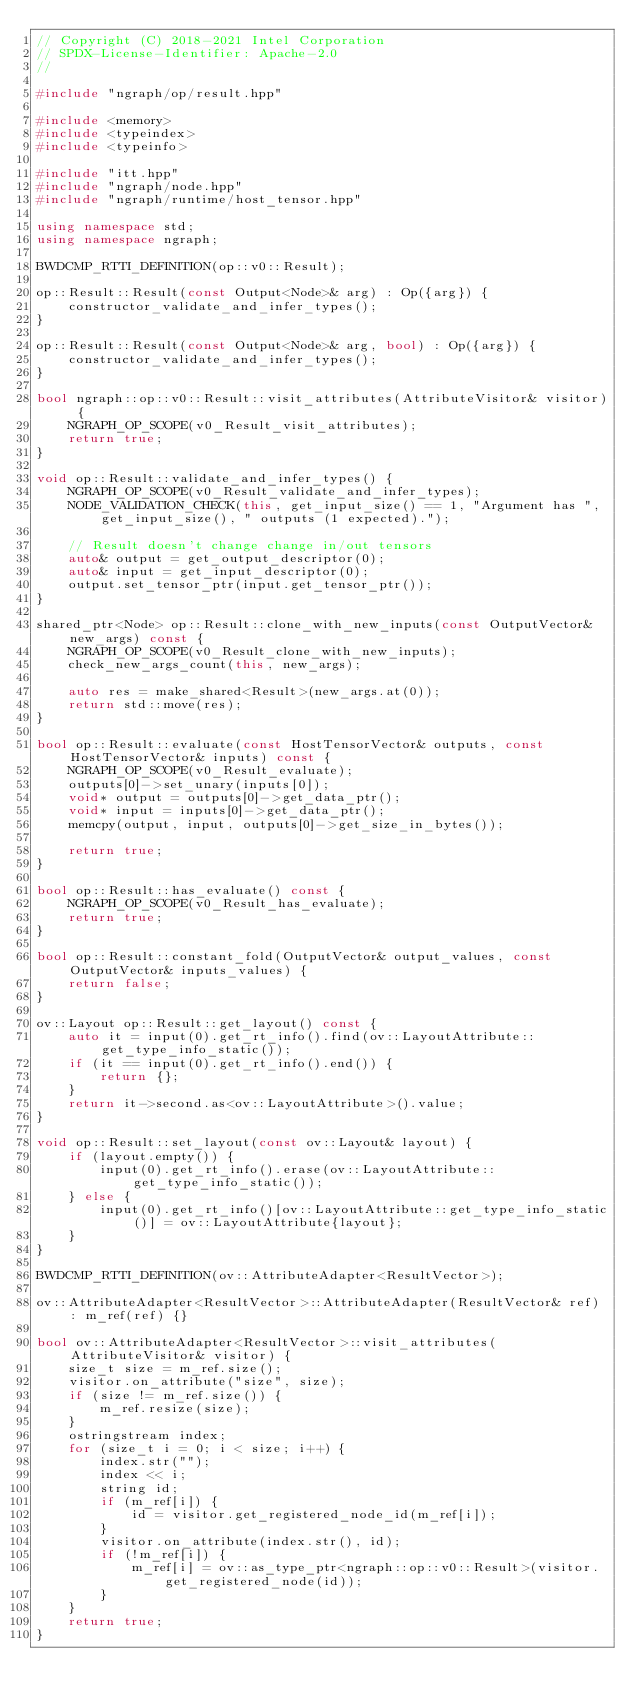<code> <loc_0><loc_0><loc_500><loc_500><_C++_>// Copyright (C) 2018-2021 Intel Corporation
// SPDX-License-Identifier: Apache-2.0
//

#include "ngraph/op/result.hpp"

#include <memory>
#include <typeindex>
#include <typeinfo>

#include "itt.hpp"
#include "ngraph/node.hpp"
#include "ngraph/runtime/host_tensor.hpp"

using namespace std;
using namespace ngraph;

BWDCMP_RTTI_DEFINITION(op::v0::Result);

op::Result::Result(const Output<Node>& arg) : Op({arg}) {
    constructor_validate_and_infer_types();
}

op::Result::Result(const Output<Node>& arg, bool) : Op({arg}) {
    constructor_validate_and_infer_types();
}

bool ngraph::op::v0::Result::visit_attributes(AttributeVisitor& visitor) {
    NGRAPH_OP_SCOPE(v0_Result_visit_attributes);
    return true;
}

void op::Result::validate_and_infer_types() {
    NGRAPH_OP_SCOPE(v0_Result_validate_and_infer_types);
    NODE_VALIDATION_CHECK(this, get_input_size() == 1, "Argument has ", get_input_size(), " outputs (1 expected).");

    // Result doesn't change change in/out tensors
    auto& output = get_output_descriptor(0);
    auto& input = get_input_descriptor(0);
    output.set_tensor_ptr(input.get_tensor_ptr());
}

shared_ptr<Node> op::Result::clone_with_new_inputs(const OutputVector& new_args) const {
    NGRAPH_OP_SCOPE(v0_Result_clone_with_new_inputs);
    check_new_args_count(this, new_args);

    auto res = make_shared<Result>(new_args.at(0));
    return std::move(res);
}

bool op::Result::evaluate(const HostTensorVector& outputs, const HostTensorVector& inputs) const {
    NGRAPH_OP_SCOPE(v0_Result_evaluate);
    outputs[0]->set_unary(inputs[0]);
    void* output = outputs[0]->get_data_ptr();
    void* input = inputs[0]->get_data_ptr();
    memcpy(output, input, outputs[0]->get_size_in_bytes());

    return true;
}

bool op::Result::has_evaluate() const {
    NGRAPH_OP_SCOPE(v0_Result_has_evaluate);
    return true;
}

bool op::Result::constant_fold(OutputVector& output_values, const OutputVector& inputs_values) {
    return false;
}

ov::Layout op::Result::get_layout() const {
    auto it = input(0).get_rt_info().find(ov::LayoutAttribute::get_type_info_static());
    if (it == input(0).get_rt_info().end()) {
        return {};
    }
    return it->second.as<ov::LayoutAttribute>().value;
}

void op::Result::set_layout(const ov::Layout& layout) {
    if (layout.empty()) {
        input(0).get_rt_info().erase(ov::LayoutAttribute::get_type_info_static());
    } else {
        input(0).get_rt_info()[ov::LayoutAttribute::get_type_info_static()] = ov::LayoutAttribute{layout};
    }
}

BWDCMP_RTTI_DEFINITION(ov::AttributeAdapter<ResultVector>);

ov::AttributeAdapter<ResultVector>::AttributeAdapter(ResultVector& ref) : m_ref(ref) {}

bool ov::AttributeAdapter<ResultVector>::visit_attributes(AttributeVisitor& visitor) {
    size_t size = m_ref.size();
    visitor.on_attribute("size", size);
    if (size != m_ref.size()) {
        m_ref.resize(size);
    }
    ostringstream index;
    for (size_t i = 0; i < size; i++) {
        index.str("");
        index << i;
        string id;
        if (m_ref[i]) {
            id = visitor.get_registered_node_id(m_ref[i]);
        }
        visitor.on_attribute(index.str(), id);
        if (!m_ref[i]) {
            m_ref[i] = ov::as_type_ptr<ngraph::op::v0::Result>(visitor.get_registered_node(id));
        }
    }
    return true;
}
</code> 